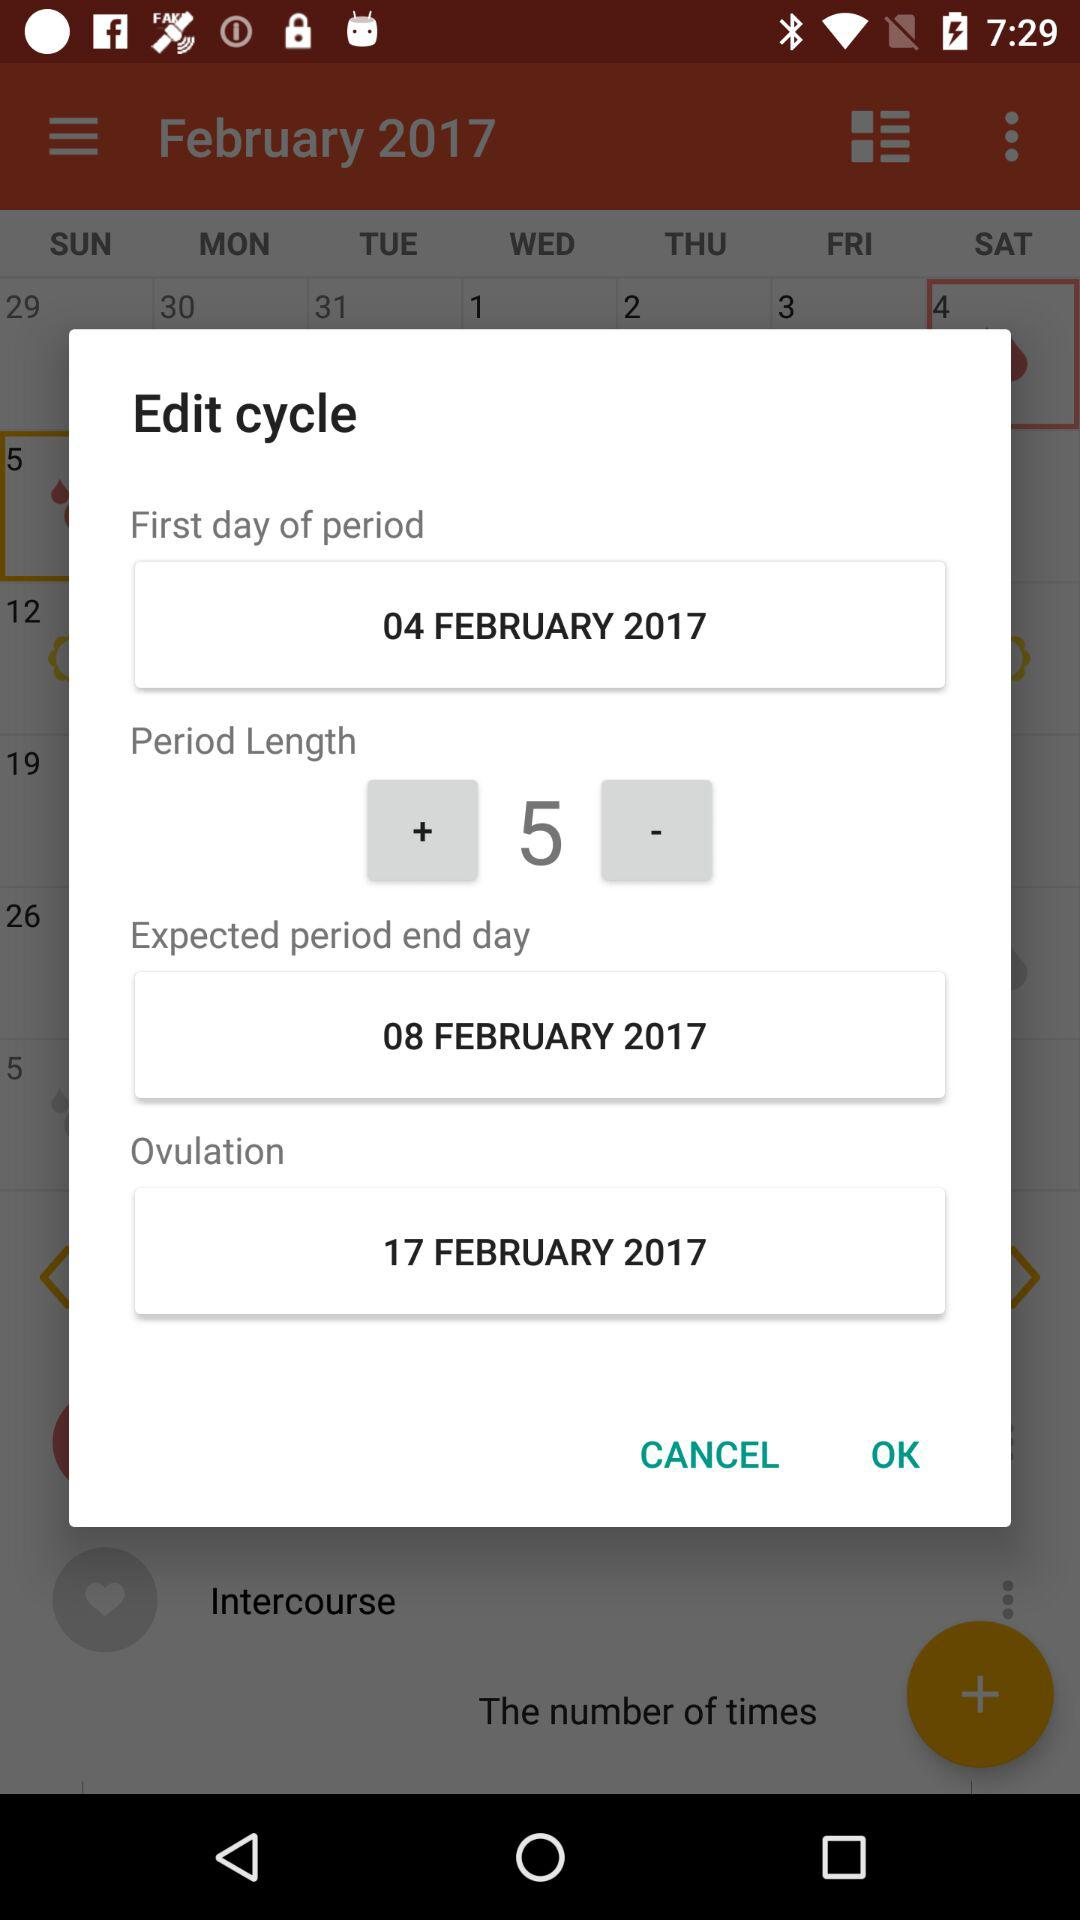What is the date of ovulation? The date of ovulation is February 17, 2017. 